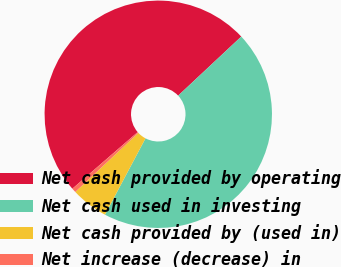<chart> <loc_0><loc_0><loc_500><loc_500><pie_chart><fcel>Net cash provided by operating<fcel>Net cash used in investing<fcel>Net cash provided by (used in)<fcel>Net increase (decrease) in<nl><fcel>49.39%<fcel>44.74%<fcel>5.26%<fcel>0.61%<nl></chart> 